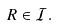<formula> <loc_0><loc_0><loc_500><loc_500>R \in \mathcal { I } .</formula> 